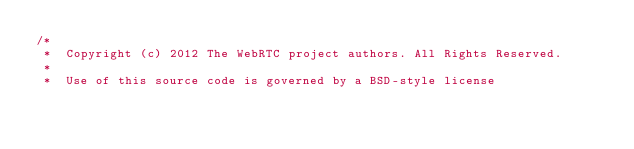<code> <loc_0><loc_0><loc_500><loc_500><_C++_>/*
 *  Copyright (c) 2012 The WebRTC project authors. All Rights Reserved.
 *
 *  Use of this source code is governed by a BSD-style license</code> 